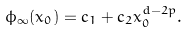<formula> <loc_0><loc_0><loc_500><loc_500>\phi _ { \infty } ( x _ { 0 } ) = c _ { 1 } + c _ { 2 } x _ { 0 } ^ { d - 2 p } .</formula> 